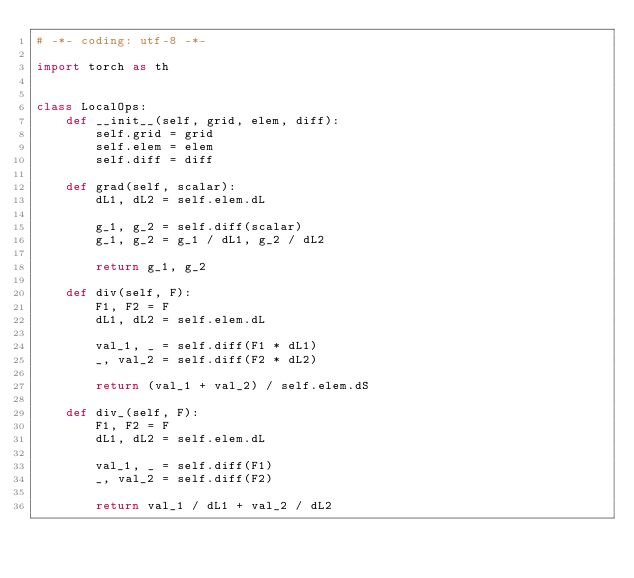<code> <loc_0><loc_0><loc_500><loc_500><_Python_># -*- coding: utf-8 -*-

import torch as th


class LocalOps:
    def __init__(self, grid, elem, diff):
        self.grid = grid
        self.elem = elem
        self.diff = diff

    def grad(self, scalar):
        dL1, dL2 = self.elem.dL

        g_1, g_2 = self.diff(scalar)
        g_1, g_2 = g_1 / dL1, g_2 / dL2

        return g_1, g_2

    def div(self, F):
        F1, F2 = F
        dL1, dL2 = self.elem.dL

        val_1, _ = self.diff(F1 * dL1)
        _, val_2 = self.diff(F2 * dL2)

        return (val_1 + val_2) / self.elem.dS

    def div_(self, F):
        F1, F2 = F
        dL1, dL2 = self.elem.dL

        val_1, _ = self.diff(F1)
        _, val_2 = self.diff(F2)

        return val_1 / dL1 + val_2 / dL2
</code> 